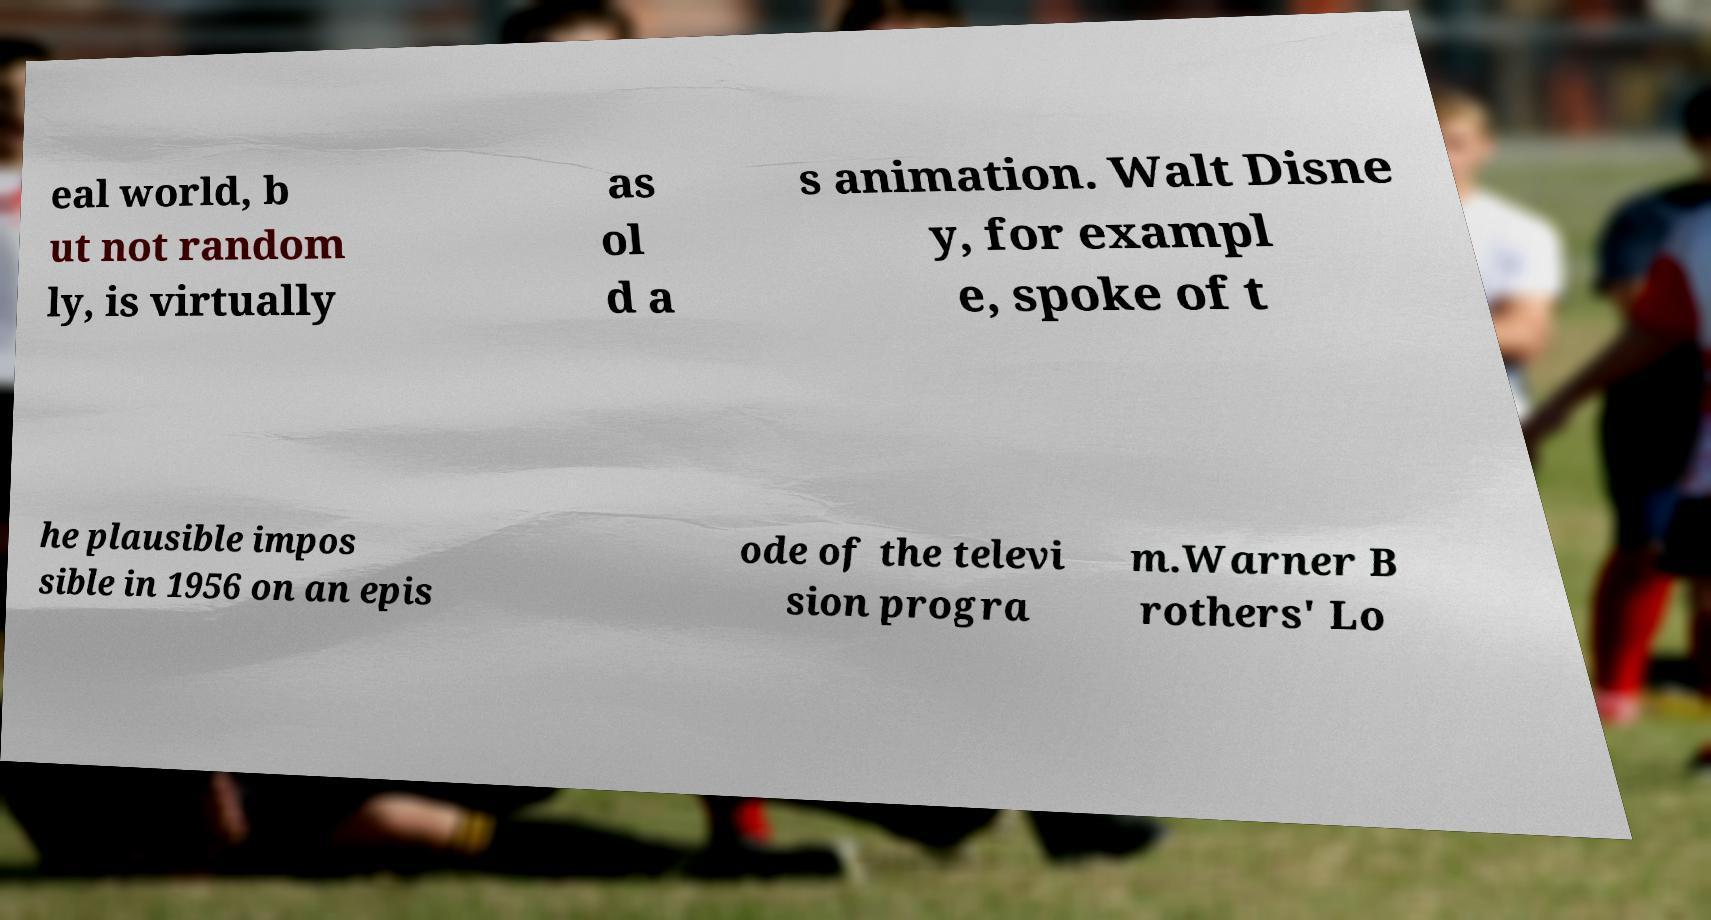There's text embedded in this image that I need extracted. Can you transcribe it verbatim? eal world, b ut not random ly, is virtually as ol d a s animation. Walt Disne y, for exampl e, spoke of t he plausible impos sible in 1956 on an epis ode of the televi sion progra m.Warner B rothers' Lo 